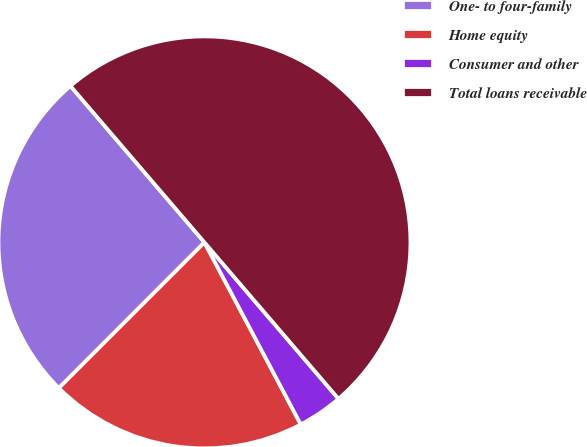Convert chart to OTSL. <chart><loc_0><loc_0><loc_500><loc_500><pie_chart><fcel>One- to four-family<fcel>Home equity<fcel>Consumer and other<fcel>Total loans receivable<nl><fcel>26.23%<fcel>20.24%<fcel>3.53%<fcel>50.0%<nl></chart> 